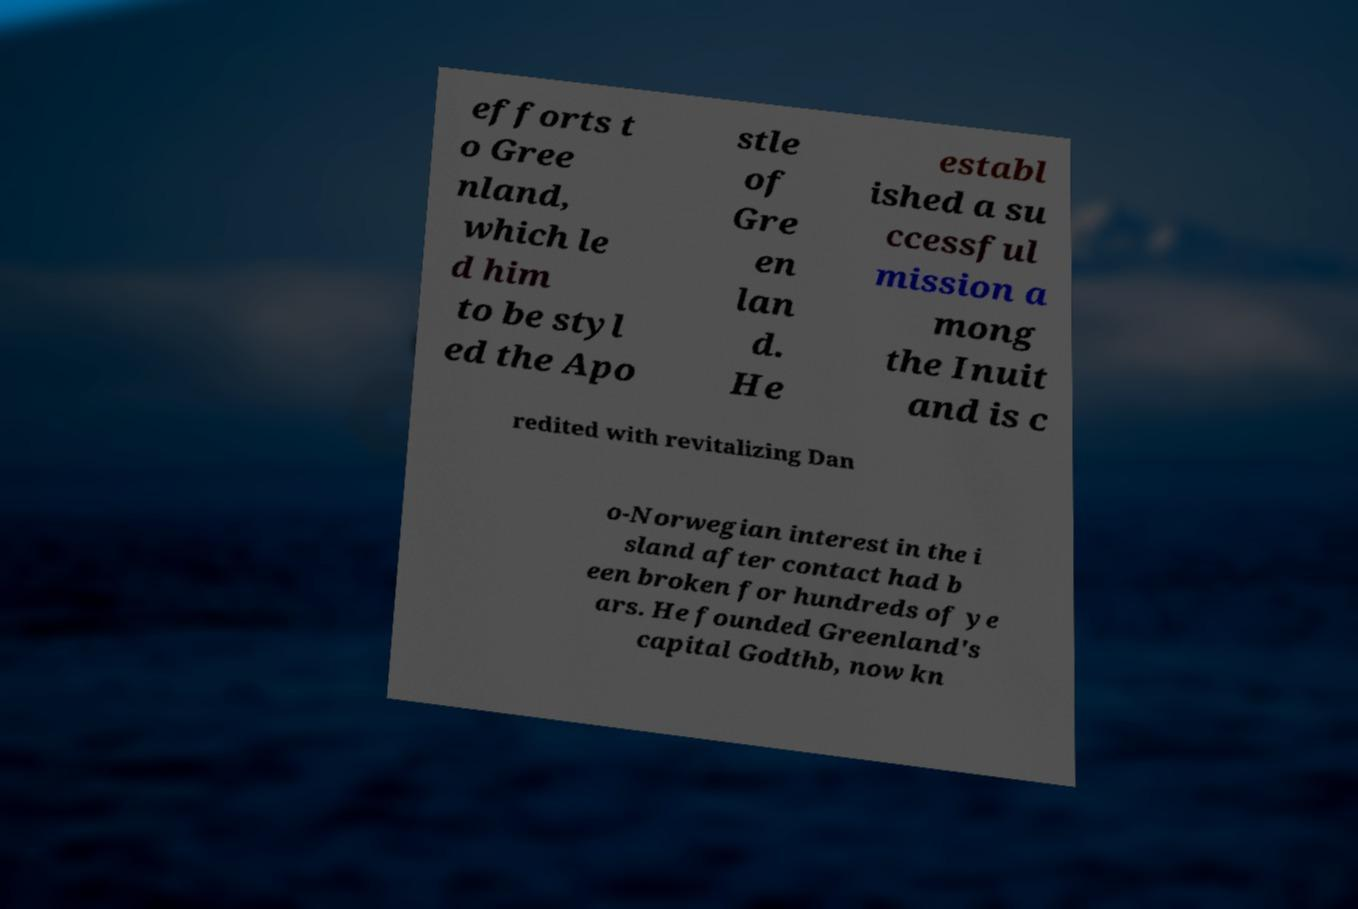Could you extract and type out the text from this image? efforts t o Gree nland, which le d him to be styl ed the Apo stle of Gre en lan d. He establ ished a su ccessful mission a mong the Inuit and is c redited with revitalizing Dan o-Norwegian interest in the i sland after contact had b een broken for hundreds of ye ars. He founded Greenland's capital Godthb, now kn 